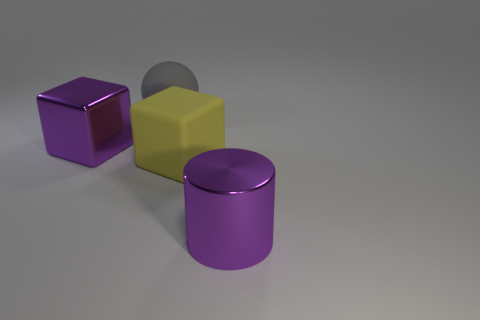Add 1 large red rubber things. How many objects exist? 5 Subtract all balls. How many objects are left? 3 Add 4 big purple cylinders. How many big purple cylinders exist? 5 Subtract 0 red cylinders. How many objects are left? 4 Subtract all blocks. Subtract all large shiny cubes. How many objects are left? 1 Add 2 purple objects. How many purple objects are left? 4 